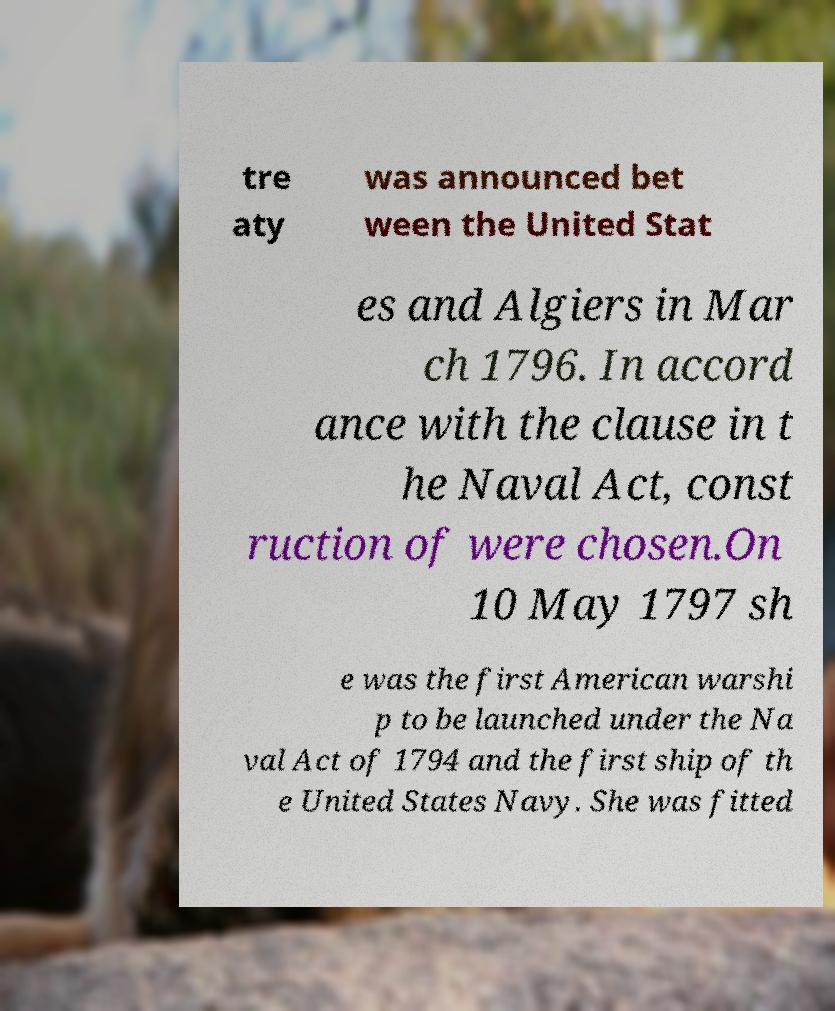Could you extract and type out the text from this image? tre aty was announced bet ween the United Stat es and Algiers in Mar ch 1796. In accord ance with the clause in t he Naval Act, const ruction of were chosen.On 10 May 1797 sh e was the first American warshi p to be launched under the Na val Act of 1794 and the first ship of th e United States Navy. She was fitted 